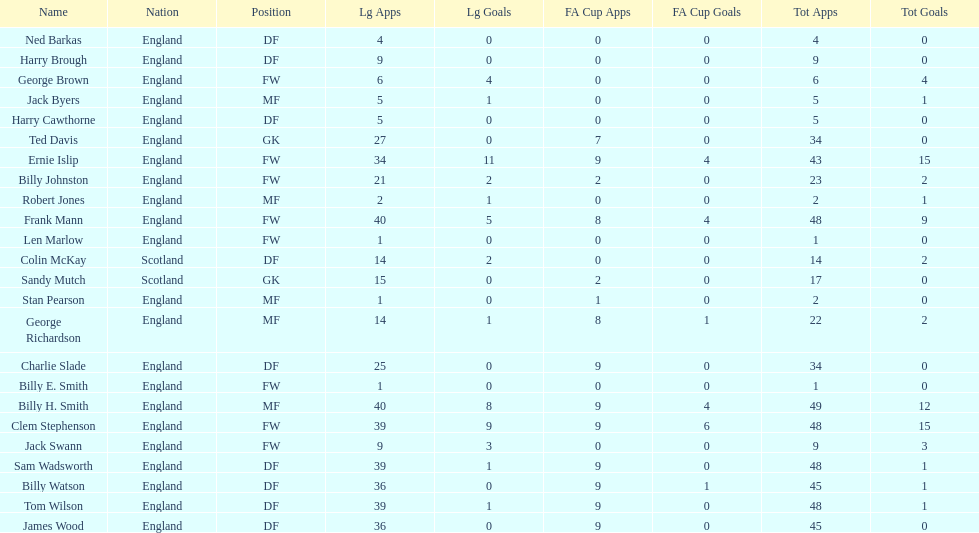How many players are fws? 8. 